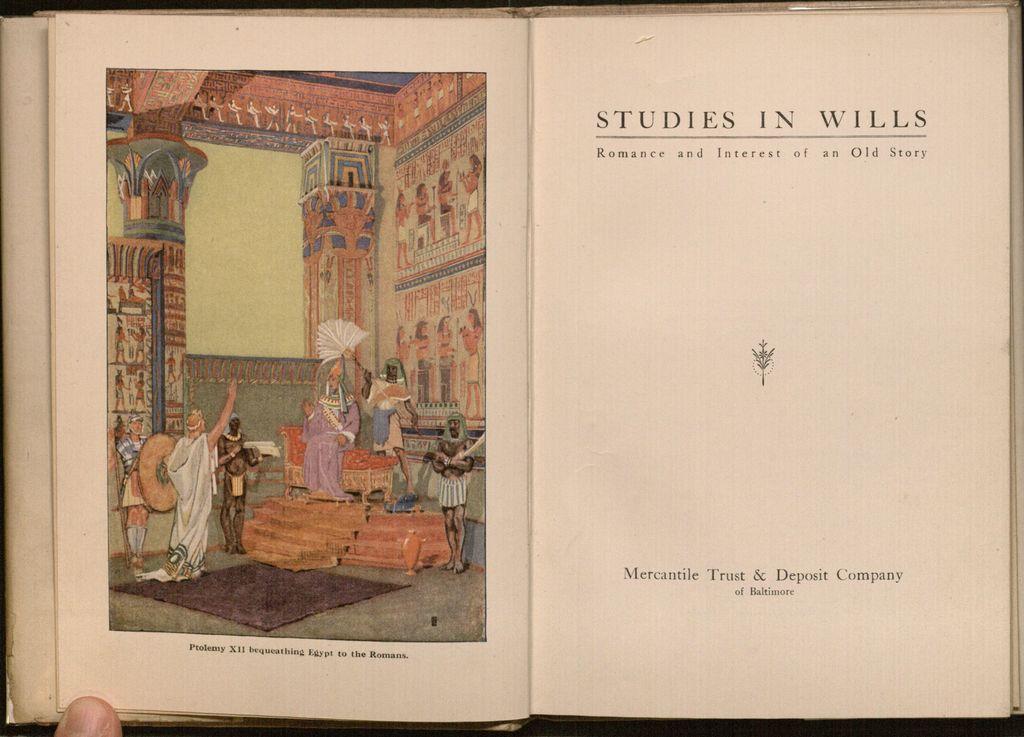What city is mentioned in the text at the bottom of the page?
Make the answer very short. Baltimore. 